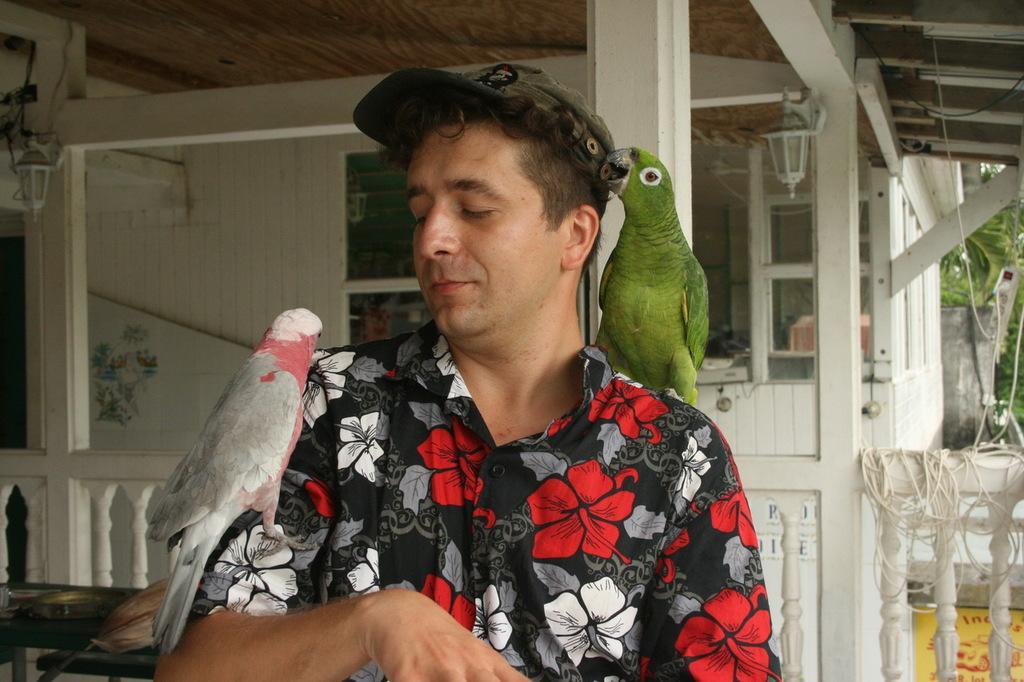Please provide a concise description of this image. In this picture we can see a man standing with a parrot on his right shoulder and a parrot on his left arm. 